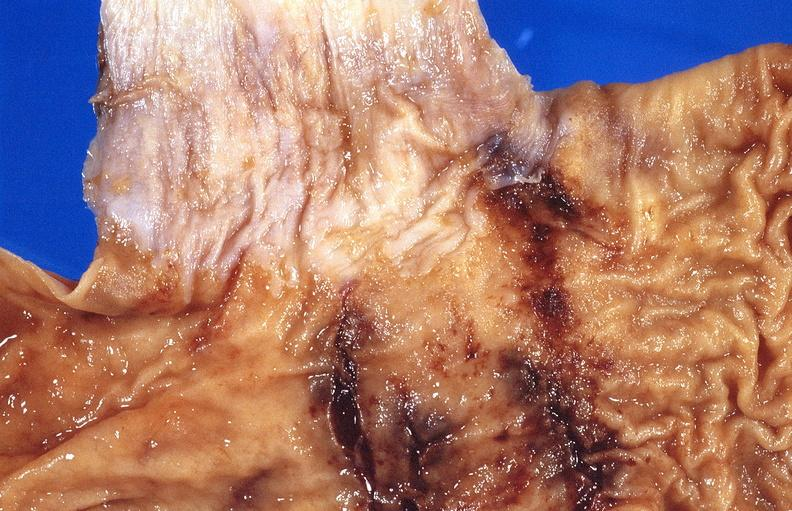s this section showing liver with tumor mass in hilar area tumor present?
Answer the question using a single word or phrase. No 